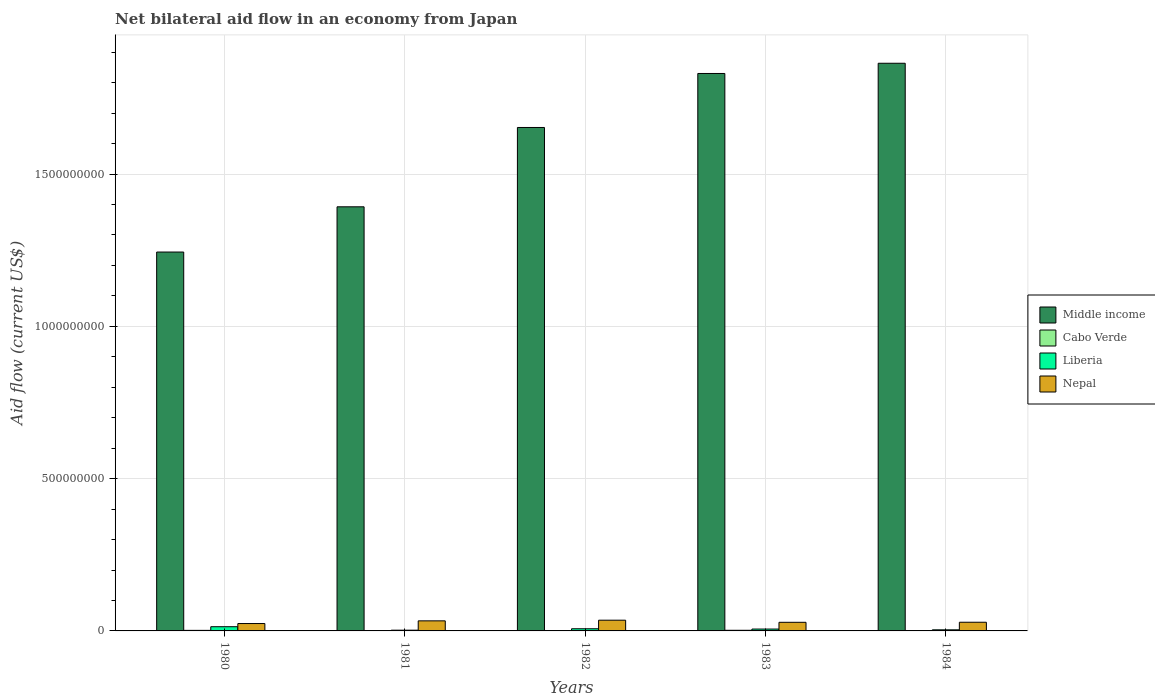How many groups of bars are there?
Give a very brief answer. 5. Are the number of bars per tick equal to the number of legend labels?
Give a very brief answer. Yes. How many bars are there on the 1st tick from the left?
Keep it short and to the point. 4. How many bars are there on the 1st tick from the right?
Provide a succinct answer. 4. In how many cases, is the number of bars for a given year not equal to the number of legend labels?
Your answer should be compact. 0. What is the net bilateral aid flow in Cabo Verde in 1984?
Provide a succinct answer. 1.02e+06. Across all years, what is the maximum net bilateral aid flow in Middle income?
Provide a succinct answer. 1.86e+09. Across all years, what is the minimum net bilateral aid flow in Middle income?
Offer a terse response. 1.24e+09. What is the total net bilateral aid flow in Middle income in the graph?
Provide a succinct answer. 7.98e+09. What is the difference between the net bilateral aid flow in Middle income in 1980 and that in 1982?
Provide a succinct answer. -4.09e+08. What is the difference between the net bilateral aid flow in Middle income in 1982 and the net bilateral aid flow in Liberia in 1980?
Make the answer very short. 1.64e+09. What is the average net bilateral aid flow in Nepal per year?
Your response must be concise. 2.99e+07. In the year 1982, what is the difference between the net bilateral aid flow in Middle income and net bilateral aid flow in Cabo Verde?
Make the answer very short. 1.65e+09. What is the ratio of the net bilateral aid flow in Middle income in 1982 to that in 1983?
Your response must be concise. 0.9. What is the difference between the highest and the lowest net bilateral aid flow in Cabo Verde?
Make the answer very short. 1.08e+06. Is the sum of the net bilateral aid flow in Liberia in 1981 and 1984 greater than the maximum net bilateral aid flow in Cabo Verde across all years?
Offer a very short reply. Yes. Is it the case that in every year, the sum of the net bilateral aid flow in Cabo Verde and net bilateral aid flow in Middle income is greater than the sum of net bilateral aid flow in Liberia and net bilateral aid flow in Nepal?
Make the answer very short. Yes. What does the 4th bar from the left in 1981 represents?
Offer a terse response. Nepal. What does the 1st bar from the right in 1980 represents?
Provide a short and direct response. Nepal. Is it the case that in every year, the sum of the net bilateral aid flow in Nepal and net bilateral aid flow in Liberia is greater than the net bilateral aid flow in Middle income?
Keep it short and to the point. No. How many bars are there?
Your answer should be compact. 20. How many years are there in the graph?
Your response must be concise. 5. What is the difference between two consecutive major ticks on the Y-axis?
Give a very brief answer. 5.00e+08. Are the values on the major ticks of Y-axis written in scientific E-notation?
Provide a succinct answer. No. How many legend labels are there?
Offer a very short reply. 4. What is the title of the graph?
Give a very brief answer. Net bilateral aid flow in an economy from Japan. What is the label or title of the Y-axis?
Make the answer very short. Aid flow (current US$). What is the Aid flow (current US$) of Middle income in 1980?
Your answer should be very brief. 1.24e+09. What is the Aid flow (current US$) in Cabo Verde in 1980?
Offer a terse response. 1.82e+06. What is the Aid flow (current US$) in Liberia in 1980?
Offer a very short reply. 1.38e+07. What is the Aid flow (current US$) of Nepal in 1980?
Your answer should be compact. 2.43e+07. What is the Aid flow (current US$) of Middle income in 1981?
Your answer should be very brief. 1.39e+09. What is the Aid flow (current US$) in Cabo Verde in 1981?
Provide a succinct answer. 1.07e+06. What is the Aid flow (current US$) in Liberia in 1981?
Your answer should be very brief. 2.46e+06. What is the Aid flow (current US$) of Nepal in 1981?
Keep it short and to the point. 3.31e+07. What is the Aid flow (current US$) of Middle income in 1982?
Provide a short and direct response. 1.65e+09. What is the Aid flow (current US$) in Cabo Verde in 1982?
Provide a succinct answer. 1.25e+06. What is the Aid flow (current US$) of Liberia in 1982?
Your answer should be compact. 7.10e+06. What is the Aid flow (current US$) in Nepal in 1982?
Your answer should be compact. 3.52e+07. What is the Aid flow (current US$) of Middle income in 1983?
Keep it short and to the point. 1.83e+09. What is the Aid flow (current US$) of Cabo Verde in 1983?
Keep it short and to the point. 2.10e+06. What is the Aid flow (current US$) of Liberia in 1983?
Keep it short and to the point. 6.13e+06. What is the Aid flow (current US$) of Nepal in 1983?
Your answer should be compact. 2.83e+07. What is the Aid flow (current US$) in Middle income in 1984?
Provide a short and direct response. 1.86e+09. What is the Aid flow (current US$) of Cabo Verde in 1984?
Give a very brief answer. 1.02e+06. What is the Aid flow (current US$) of Liberia in 1984?
Ensure brevity in your answer.  3.63e+06. What is the Aid flow (current US$) of Nepal in 1984?
Your response must be concise. 2.85e+07. Across all years, what is the maximum Aid flow (current US$) in Middle income?
Offer a terse response. 1.86e+09. Across all years, what is the maximum Aid flow (current US$) of Cabo Verde?
Offer a terse response. 2.10e+06. Across all years, what is the maximum Aid flow (current US$) of Liberia?
Your response must be concise. 1.38e+07. Across all years, what is the maximum Aid flow (current US$) of Nepal?
Provide a succinct answer. 3.52e+07. Across all years, what is the minimum Aid flow (current US$) in Middle income?
Offer a very short reply. 1.24e+09. Across all years, what is the minimum Aid flow (current US$) in Cabo Verde?
Make the answer very short. 1.02e+06. Across all years, what is the minimum Aid flow (current US$) of Liberia?
Offer a terse response. 2.46e+06. Across all years, what is the minimum Aid flow (current US$) of Nepal?
Provide a succinct answer. 2.43e+07. What is the total Aid flow (current US$) in Middle income in the graph?
Give a very brief answer. 7.98e+09. What is the total Aid flow (current US$) of Cabo Verde in the graph?
Provide a succinct answer. 7.26e+06. What is the total Aid flow (current US$) in Liberia in the graph?
Offer a very short reply. 3.32e+07. What is the total Aid flow (current US$) in Nepal in the graph?
Give a very brief answer. 1.49e+08. What is the difference between the Aid flow (current US$) in Middle income in 1980 and that in 1981?
Ensure brevity in your answer.  -1.49e+08. What is the difference between the Aid flow (current US$) of Cabo Verde in 1980 and that in 1981?
Your answer should be very brief. 7.50e+05. What is the difference between the Aid flow (current US$) of Liberia in 1980 and that in 1981?
Make the answer very short. 1.14e+07. What is the difference between the Aid flow (current US$) of Nepal in 1980 and that in 1981?
Your answer should be compact. -8.81e+06. What is the difference between the Aid flow (current US$) of Middle income in 1980 and that in 1982?
Offer a very short reply. -4.09e+08. What is the difference between the Aid flow (current US$) in Cabo Verde in 1980 and that in 1982?
Give a very brief answer. 5.70e+05. What is the difference between the Aid flow (current US$) in Liberia in 1980 and that in 1982?
Your answer should be very brief. 6.75e+06. What is the difference between the Aid flow (current US$) of Nepal in 1980 and that in 1982?
Provide a succinct answer. -1.10e+07. What is the difference between the Aid flow (current US$) of Middle income in 1980 and that in 1983?
Provide a short and direct response. -5.86e+08. What is the difference between the Aid flow (current US$) in Cabo Verde in 1980 and that in 1983?
Your answer should be compact. -2.80e+05. What is the difference between the Aid flow (current US$) of Liberia in 1980 and that in 1983?
Your answer should be compact. 7.72e+06. What is the difference between the Aid flow (current US$) in Nepal in 1980 and that in 1983?
Your answer should be compact. -4.05e+06. What is the difference between the Aid flow (current US$) in Middle income in 1980 and that in 1984?
Provide a short and direct response. -6.20e+08. What is the difference between the Aid flow (current US$) in Cabo Verde in 1980 and that in 1984?
Offer a terse response. 8.00e+05. What is the difference between the Aid flow (current US$) of Liberia in 1980 and that in 1984?
Your answer should be compact. 1.02e+07. What is the difference between the Aid flow (current US$) of Nepal in 1980 and that in 1984?
Keep it short and to the point. -4.26e+06. What is the difference between the Aid flow (current US$) in Middle income in 1981 and that in 1982?
Keep it short and to the point. -2.60e+08. What is the difference between the Aid flow (current US$) in Cabo Verde in 1981 and that in 1982?
Your answer should be very brief. -1.80e+05. What is the difference between the Aid flow (current US$) of Liberia in 1981 and that in 1982?
Provide a succinct answer. -4.64e+06. What is the difference between the Aid flow (current US$) in Nepal in 1981 and that in 1982?
Offer a very short reply. -2.15e+06. What is the difference between the Aid flow (current US$) in Middle income in 1981 and that in 1983?
Your answer should be compact. -4.38e+08. What is the difference between the Aid flow (current US$) of Cabo Verde in 1981 and that in 1983?
Offer a terse response. -1.03e+06. What is the difference between the Aid flow (current US$) of Liberia in 1981 and that in 1983?
Keep it short and to the point. -3.67e+06. What is the difference between the Aid flow (current US$) of Nepal in 1981 and that in 1983?
Your response must be concise. 4.76e+06. What is the difference between the Aid flow (current US$) in Middle income in 1981 and that in 1984?
Your answer should be very brief. -4.71e+08. What is the difference between the Aid flow (current US$) of Cabo Verde in 1981 and that in 1984?
Your answer should be very brief. 5.00e+04. What is the difference between the Aid flow (current US$) of Liberia in 1981 and that in 1984?
Your answer should be compact. -1.17e+06. What is the difference between the Aid flow (current US$) of Nepal in 1981 and that in 1984?
Your answer should be compact. 4.55e+06. What is the difference between the Aid flow (current US$) in Middle income in 1982 and that in 1983?
Offer a very short reply. -1.77e+08. What is the difference between the Aid flow (current US$) of Cabo Verde in 1982 and that in 1983?
Your answer should be compact. -8.50e+05. What is the difference between the Aid flow (current US$) of Liberia in 1982 and that in 1983?
Offer a terse response. 9.70e+05. What is the difference between the Aid flow (current US$) in Nepal in 1982 and that in 1983?
Your answer should be compact. 6.91e+06. What is the difference between the Aid flow (current US$) of Middle income in 1982 and that in 1984?
Provide a short and direct response. -2.11e+08. What is the difference between the Aid flow (current US$) in Liberia in 1982 and that in 1984?
Keep it short and to the point. 3.47e+06. What is the difference between the Aid flow (current US$) in Nepal in 1982 and that in 1984?
Your answer should be compact. 6.70e+06. What is the difference between the Aid flow (current US$) in Middle income in 1983 and that in 1984?
Make the answer very short. -3.35e+07. What is the difference between the Aid flow (current US$) in Cabo Verde in 1983 and that in 1984?
Your answer should be compact. 1.08e+06. What is the difference between the Aid flow (current US$) of Liberia in 1983 and that in 1984?
Your response must be concise. 2.50e+06. What is the difference between the Aid flow (current US$) in Middle income in 1980 and the Aid flow (current US$) in Cabo Verde in 1981?
Keep it short and to the point. 1.24e+09. What is the difference between the Aid flow (current US$) in Middle income in 1980 and the Aid flow (current US$) in Liberia in 1981?
Give a very brief answer. 1.24e+09. What is the difference between the Aid flow (current US$) in Middle income in 1980 and the Aid flow (current US$) in Nepal in 1981?
Make the answer very short. 1.21e+09. What is the difference between the Aid flow (current US$) in Cabo Verde in 1980 and the Aid flow (current US$) in Liberia in 1981?
Offer a terse response. -6.40e+05. What is the difference between the Aid flow (current US$) of Cabo Verde in 1980 and the Aid flow (current US$) of Nepal in 1981?
Offer a very short reply. -3.12e+07. What is the difference between the Aid flow (current US$) of Liberia in 1980 and the Aid flow (current US$) of Nepal in 1981?
Provide a short and direct response. -1.92e+07. What is the difference between the Aid flow (current US$) in Middle income in 1980 and the Aid flow (current US$) in Cabo Verde in 1982?
Provide a short and direct response. 1.24e+09. What is the difference between the Aid flow (current US$) of Middle income in 1980 and the Aid flow (current US$) of Liberia in 1982?
Provide a short and direct response. 1.24e+09. What is the difference between the Aid flow (current US$) in Middle income in 1980 and the Aid flow (current US$) in Nepal in 1982?
Your answer should be compact. 1.21e+09. What is the difference between the Aid flow (current US$) of Cabo Verde in 1980 and the Aid flow (current US$) of Liberia in 1982?
Offer a very short reply. -5.28e+06. What is the difference between the Aid flow (current US$) of Cabo Verde in 1980 and the Aid flow (current US$) of Nepal in 1982?
Provide a succinct answer. -3.34e+07. What is the difference between the Aid flow (current US$) in Liberia in 1980 and the Aid flow (current US$) in Nepal in 1982?
Give a very brief answer. -2.14e+07. What is the difference between the Aid flow (current US$) in Middle income in 1980 and the Aid flow (current US$) in Cabo Verde in 1983?
Your answer should be compact. 1.24e+09. What is the difference between the Aid flow (current US$) of Middle income in 1980 and the Aid flow (current US$) of Liberia in 1983?
Ensure brevity in your answer.  1.24e+09. What is the difference between the Aid flow (current US$) of Middle income in 1980 and the Aid flow (current US$) of Nepal in 1983?
Your answer should be compact. 1.22e+09. What is the difference between the Aid flow (current US$) in Cabo Verde in 1980 and the Aid flow (current US$) in Liberia in 1983?
Your answer should be very brief. -4.31e+06. What is the difference between the Aid flow (current US$) of Cabo Verde in 1980 and the Aid flow (current US$) of Nepal in 1983?
Make the answer very short. -2.65e+07. What is the difference between the Aid flow (current US$) of Liberia in 1980 and the Aid flow (current US$) of Nepal in 1983?
Keep it short and to the point. -1.45e+07. What is the difference between the Aid flow (current US$) in Middle income in 1980 and the Aid flow (current US$) in Cabo Verde in 1984?
Keep it short and to the point. 1.24e+09. What is the difference between the Aid flow (current US$) of Middle income in 1980 and the Aid flow (current US$) of Liberia in 1984?
Keep it short and to the point. 1.24e+09. What is the difference between the Aid flow (current US$) of Middle income in 1980 and the Aid flow (current US$) of Nepal in 1984?
Give a very brief answer. 1.22e+09. What is the difference between the Aid flow (current US$) in Cabo Verde in 1980 and the Aid flow (current US$) in Liberia in 1984?
Your response must be concise. -1.81e+06. What is the difference between the Aid flow (current US$) of Cabo Verde in 1980 and the Aid flow (current US$) of Nepal in 1984?
Your answer should be compact. -2.67e+07. What is the difference between the Aid flow (current US$) in Liberia in 1980 and the Aid flow (current US$) in Nepal in 1984?
Offer a very short reply. -1.47e+07. What is the difference between the Aid flow (current US$) in Middle income in 1981 and the Aid flow (current US$) in Cabo Verde in 1982?
Provide a short and direct response. 1.39e+09. What is the difference between the Aid flow (current US$) in Middle income in 1981 and the Aid flow (current US$) in Liberia in 1982?
Your answer should be compact. 1.39e+09. What is the difference between the Aid flow (current US$) of Middle income in 1981 and the Aid flow (current US$) of Nepal in 1982?
Your response must be concise. 1.36e+09. What is the difference between the Aid flow (current US$) of Cabo Verde in 1981 and the Aid flow (current US$) of Liberia in 1982?
Offer a terse response. -6.03e+06. What is the difference between the Aid flow (current US$) in Cabo Verde in 1981 and the Aid flow (current US$) in Nepal in 1982?
Offer a very short reply. -3.42e+07. What is the difference between the Aid flow (current US$) of Liberia in 1981 and the Aid flow (current US$) of Nepal in 1982?
Ensure brevity in your answer.  -3.28e+07. What is the difference between the Aid flow (current US$) in Middle income in 1981 and the Aid flow (current US$) in Cabo Verde in 1983?
Give a very brief answer. 1.39e+09. What is the difference between the Aid flow (current US$) in Middle income in 1981 and the Aid flow (current US$) in Liberia in 1983?
Offer a very short reply. 1.39e+09. What is the difference between the Aid flow (current US$) in Middle income in 1981 and the Aid flow (current US$) in Nepal in 1983?
Give a very brief answer. 1.36e+09. What is the difference between the Aid flow (current US$) of Cabo Verde in 1981 and the Aid flow (current US$) of Liberia in 1983?
Offer a very short reply. -5.06e+06. What is the difference between the Aid flow (current US$) of Cabo Verde in 1981 and the Aid flow (current US$) of Nepal in 1983?
Give a very brief answer. -2.72e+07. What is the difference between the Aid flow (current US$) in Liberia in 1981 and the Aid flow (current US$) in Nepal in 1983?
Provide a short and direct response. -2.58e+07. What is the difference between the Aid flow (current US$) in Middle income in 1981 and the Aid flow (current US$) in Cabo Verde in 1984?
Offer a very short reply. 1.39e+09. What is the difference between the Aid flow (current US$) in Middle income in 1981 and the Aid flow (current US$) in Liberia in 1984?
Offer a terse response. 1.39e+09. What is the difference between the Aid flow (current US$) in Middle income in 1981 and the Aid flow (current US$) in Nepal in 1984?
Provide a succinct answer. 1.36e+09. What is the difference between the Aid flow (current US$) of Cabo Verde in 1981 and the Aid flow (current US$) of Liberia in 1984?
Provide a short and direct response. -2.56e+06. What is the difference between the Aid flow (current US$) in Cabo Verde in 1981 and the Aid flow (current US$) in Nepal in 1984?
Your answer should be compact. -2.74e+07. What is the difference between the Aid flow (current US$) in Liberia in 1981 and the Aid flow (current US$) in Nepal in 1984?
Make the answer very short. -2.61e+07. What is the difference between the Aid flow (current US$) of Middle income in 1982 and the Aid flow (current US$) of Cabo Verde in 1983?
Provide a short and direct response. 1.65e+09. What is the difference between the Aid flow (current US$) of Middle income in 1982 and the Aid flow (current US$) of Liberia in 1983?
Offer a terse response. 1.65e+09. What is the difference between the Aid flow (current US$) of Middle income in 1982 and the Aid flow (current US$) of Nepal in 1983?
Make the answer very short. 1.62e+09. What is the difference between the Aid flow (current US$) of Cabo Verde in 1982 and the Aid flow (current US$) of Liberia in 1983?
Ensure brevity in your answer.  -4.88e+06. What is the difference between the Aid flow (current US$) of Cabo Verde in 1982 and the Aid flow (current US$) of Nepal in 1983?
Make the answer very short. -2.71e+07. What is the difference between the Aid flow (current US$) of Liberia in 1982 and the Aid flow (current US$) of Nepal in 1983?
Your answer should be very brief. -2.12e+07. What is the difference between the Aid flow (current US$) in Middle income in 1982 and the Aid flow (current US$) in Cabo Verde in 1984?
Provide a short and direct response. 1.65e+09. What is the difference between the Aid flow (current US$) of Middle income in 1982 and the Aid flow (current US$) of Liberia in 1984?
Your response must be concise. 1.65e+09. What is the difference between the Aid flow (current US$) in Middle income in 1982 and the Aid flow (current US$) in Nepal in 1984?
Make the answer very short. 1.62e+09. What is the difference between the Aid flow (current US$) in Cabo Verde in 1982 and the Aid flow (current US$) in Liberia in 1984?
Keep it short and to the point. -2.38e+06. What is the difference between the Aid flow (current US$) of Cabo Verde in 1982 and the Aid flow (current US$) of Nepal in 1984?
Give a very brief answer. -2.73e+07. What is the difference between the Aid flow (current US$) of Liberia in 1982 and the Aid flow (current US$) of Nepal in 1984?
Make the answer very short. -2.14e+07. What is the difference between the Aid flow (current US$) in Middle income in 1983 and the Aid flow (current US$) in Cabo Verde in 1984?
Make the answer very short. 1.83e+09. What is the difference between the Aid flow (current US$) in Middle income in 1983 and the Aid flow (current US$) in Liberia in 1984?
Ensure brevity in your answer.  1.83e+09. What is the difference between the Aid flow (current US$) in Middle income in 1983 and the Aid flow (current US$) in Nepal in 1984?
Provide a short and direct response. 1.80e+09. What is the difference between the Aid flow (current US$) in Cabo Verde in 1983 and the Aid flow (current US$) in Liberia in 1984?
Ensure brevity in your answer.  -1.53e+06. What is the difference between the Aid flow (current US$) in Cabo Verde in 1983 and the Aid flow (current US$) in Nepal in 1984?
Your answer should be very brief. -2.64e+07. What is the difference between the Aid flow (current US$) in Liberia in 1983 and the Aid flow (current US$) in Nepal in 1984?
Offer a terse response. -2.24e+07. What is the average Aid flow (current US$) of Middle income per year?
Make the answer very short. 1.60e+09. What is the average Aid flow (current US$) of Cabo Verde per year?
Make the answer very short. 1.45e+06. What is the average Aid flow (current US$) in Liberia per year?
Make the answer very short. 6.63e+06. What is the average Aid flow (current US$) of Nepal per year?
Keep it short and to the point. 2.99e+07. In the year 1980, what is the difference between the Aid flow (current US$) of Middle income and Aid flow (current US$) of Cabo Verde?
Keep it short and to the point. 1.24e+09. In the year 1980, what is the difference between the Aid flow (current US$) of Middle income and Aid flow (current US$) of Liberia?
Make the answer very short. 1.23e+09. In the year 1980, what is the difference between the Aid flow (current US$) in Middle income and Aid flow (current US$) in Nepal?
Keep it short and to the point. 1.22e+09. In the year 1980, what is the difference between the Aid flow (current US$) in Cabo Verde and Aid flow (current US$) in Liberia?
Provide a short and direct response. -1.20e+07. In the year 1980, what is the difference between the Aid flow (current US$) in Cabo Verde and Aid flow (current US$) in Nepal?
Provide a short and direct response. -2.24e+07. In the year 1980, what is the difference between the Aid flow (current US$) in Liberia and Aid flow (current US$) in Nepal?
Provide a succinct answer. -1.04e+07. In the year 1981, what is the difference between the Aid flow (current US$) of Middle income and Aid flow (current US$) of Cabo Verde?
Your response must be concise. 1.39e+09. In the year 1981, what is the difference between the Aid flow (current US$) in Middle income and Aid flow (current US$) in Liberia?
Provide a succinct answer. 1.39e+09. In the year 1981, what is the difference between the Aid flow (current US$) of Middle income and Aid flow (current US$) of Nepal?
Your answer should be compact. 1.36e+09. In the year 1981, what is the difference between the Aid flow (current US$) of Cabo Verde and Aid flow (current US$) of Liberia?
Your answer should be very brief. -1.39e+06. In the year 1981, what is the difference between the Aid flow (current US$) of Cabo Verde and Aid flow (current US$) of Nepal?
Your response must be concise. -3.20e+07. In the year 1981, what is the difference between the Aid flow (current US$) of Liberia and Aid flow (current US$) of Nepal?
Provide a short and direct response. -3.06e+07. In the year 1982, what is the difference between the Aid flow (current US$) in Middle income and Aid flow (current US$) in Cabo Verde?
Ensure brevity in your answer.  1.65e+09. In the year 1982, what is the difference between the Aid flow (current US$) of Middle income and Aid flow (current US$) of Liberia?
Provide a succinct answer. 1.65e+09. In the year 1982, what is the difference between the Aid flow (current US$) in Middle income and Aid flow (current US$) in Nepal?
Make the answer very short. 1.62e+09. In the year 1982, what is the difference between the Aid flow (current US$) in Cabo Verde and Aid flow (current US$) in Liberia?
Keep it short and to the point. -5.85e+06. In the year 1982, what is the difference between the Aid flow (current US$) of Cabo Verde and Aid flow (current US$) of Nepal?
Provide a short and direct response. -3.40e+07. In the year 1982, what is the difference between the Aid flow (current US$) in Liberia and Aid flow (current US$) in Nepal?
Offer a terse response. -2.81e+07. In the year 1983, what is the difference between the Aid flow (current US$) of Middle income and Aid flow (current US$) of Cabo Verde?
Provide a succinct answer. 1.83e+09. In the year 1983, what is the difference between the Aid flow (current US$) in Middle income and Aid flow (current US$) in Liberia?
Ensure brevity in your answer.  1.82e+09. In the year 1983, what is the difference between the Aid flow (current US$) in Middle income and Aid flow (current US$) in Nepal?
Provide a short and direct response. 1.80e+09. In the year 1983, what is the difference between the Aid flow (current US$) of Cabo Verde and Aid flow (current US$) of Liberia?
Provide a short and direct response. -4.03e+06. In the year 1983, what is the difference between the Aid flow (current US$) in Cabo Verde and Aid flow (current US$) in Nepal?
Your answer should be compact. -2.62e+07. In the year 1983, what is the difference between the Aid flow (current US$) in Liberia and Aid flow (current US$) in Nepal?
Keep it short and to the point. -2.22e+07. In the year 1984, what is the difference between the Aid flow (current US$) of Middle income and Aid flow (current US$) of Cabo Verde?
Give a very brief answer. 1.86e+09. In the year 1984, what is the difference between the Aid flow (current US$) in Middle income and Aid flow (current US$) in Liberia?
Offer a terse response. 1.86e+09. In the year 1984, what is the difference between the Aid flow (current US$) in Middle income and Aid flow (current US$) in Nepal?
Provide a short and direct response. 1.84e+09. In the year 1984, what is the difference between the Aid flow (current US$) in Cabo Verde and Aid flow (current US$) in Liberia?
Keep it short and to the point. -2.61e+06. In the year 1984, what is the difference between the Aid flow (current US$) of Cabo Verde and Aid flow (current US$) of Nepal?
Offer a terse response. -2.75e+07. In the year 1984, what is the difference between the Aid flow (current US$) of Liberia and Aid flow (current US$) of Nepal?
Offer a very short reply. -2.49e+07. What is the ratio of the Aid flow (current US$) of Middle income in 1980 to that in 1981?
Offer a terse response. 0.89. What is the ratio of the Aid flow (current US$) in Cabo Verde in 1980 to that in 1981?
Your response must be concise. 1.7. What is the ratio of the Aid flow (current US$) of Liberia in 1980 to that in 1981?
Your response must be concise. 5.63. What is the ratio of the Aid flow (current US$) of Nepal in 1980 to that in 1981?
Offer a terse response. 0.73. What is the ratio of the Aid flow (current US$) of Middle income in 1980 to that in 1982?
Make the answer very short. 0.75. What is the ratio of the Aid flow (current US$) of Cabo Verde in 1980 to that in 1982?
Your answer should be very brief. 1.46. What is the ratio of the Aid flow (current US$) in Liberia in 1980 to that in 1982?
Your response must be concise. 1.95. What is the ratio of the Aid flow (current US$) in Nepal in 1980 to that in 1982?
Your answer should be very brief. 0.69. What is the ratio of the Aid flow (current US$) of Middle income in 1980 to that in 1983?
Make the answer very short. 0.68. What is the ratio of the Aid flow (current US$) of Cabo Verde in 1980 to that in 1983?
Provide a short and direct response. 0.87. What is the ratio of the Aid flow (current US$) in Liberia in 1980 to that in 1983?
Your answer should be very brief. 2.26. What is the ratio of the Aid flow (current US$) of Nepal in 1980 to that in 1983?
Your answer should be very brief. 0.86. What is the ratio of the Aid flow (current US$) of Middle income in 1980 to that in 1984?
Your answer should be compact. 0.67. What is the ratio of the Aid flow (current US$) of Cabo Verde in 1980 to that in 1984?
Offer a terse response. 1.78. What is the ratio of the Aid flow (current US$) in Liberia in 1980 to that in 1984?
Give a very brief answer. 3.82. What is the ratio of the Aid flow (current US$) of Nepal in 1980 to that in 1984?
Provide a short and direct response. 0.85. What is the ratio of the Aid flow (current US$) in Middle income in 1981 to that in 1982?
Give a very brief answer. 0.84. What is the ratio of the Aid flow (current US$) of Cabo Verde in 1981 to that in 1982?
Provide a short and direct response. 0.86. What is the ratio of the Aid flow (current US$) of Liberia in 1981 to that in 1982?
Keep it short and to the point. 0.35. What is the ratio of the Aid flow (current US$) in Nepal in 1981 to that in 1982?
Keep it short and to the point. 0.94. What is the ratio of the Aid flow (current US$) of Middle income in 1981 to that in 1983?
Your response must be concise. 0.76. What is the ratio of the Aid flow (current US$) of Cabo Verde in 1981 to that in 1983?
Your response must be concise. 0.51. What is the ratio of the Aid flow (current US$) of Liberia in 1981 to that in 1983?
Offer a terse response. 0.4. What is the ratio of the Aid flow (current US$) in Nepal in 1981 to that in 1983?
Give a very brief answer. 1.17. What is the ratio of the Aid flow (current US$) in Middle income in 1981 to that in 1984?
Your answer should be compact. 0.75. What is the ratio of the Aid flow (current US$) in Cabo Verde in 1981 to that in 1984?
Give a very brief answer. 1.05. What is the ratio of the Aid flow (current US$) of Liberia in 1981 to that in 1984?
Your response must be concise. 0.68. What is the ratio of the Aid flow (current US$) of Nepal in 1981 to that in 1984?
Offer a very short reply. 1.16. What is the ratio of the Aid flow (current US$) in Middle income in 1982 to that in 1983?
Provide a short and direct response. 0.9. What is the ratio of the Aid flow (current US$) of Cabo Verde in 1982 to that in 1983?
Offer a very short reply. 0.6. What is the ratio of the Aid flow (current US$) in Liberia in 1982 to that in 1983?
Ensure brevity in your answer.  1.16. What is the ratio of the Aid flow (current US$) in Nepal in 1982 to that in 1983?
Provide a short and direct response. 1.24. What is the ratio of the Aid flow (current US$) of Middle income in 1982 to that in 1984?
Offer a terse response. 0.89. What is the ratio of the Aid flow (current US$) of Cabo Verde in 1982 to that in 1984?
Your response must be concise. 1.23. What is the ratio of the Aid flow (current US$) of Liberia in 1982 to that in 1984?
Provide a short and direct response. 1.96. What is the ratio of the Aid flow (current US$) in Nepal in 1982 to that in 1984?
Provide a short and direct response. 1.23. What is the ratio of the Aid flow (current US$) in Cabo Verde in 1983 to that in 1984?
Your answer should be compact. 2.06. What is the ratio of the Aid flow (current US$) in Liberia in 1983 to that in 1984?
Offer a terse response. 1.69. What is the ratio of the Aid flow (current US$) of Nepal in 1983 to that in 1984?
Ensure brevity in your answer.  0.99. What is the difference between the highest and the second highest Aid flow (current US$) of Middle income?
Ensure brevity in your answer.  3.35e+07. What is the difference between the highest and the second highest Aid flow (current US$) in Cabo Verde?
Your answer should be compact. 2.80e+05. What is the difference between the highest and the second highest Aid flow (current US$) of Liberia?
Your response must be concise. 6.75e+06. What is the difference between the highest and the second highest Aid flow (current US$) in Nepal?
Your answer should be compact. 2.15e+06. What is the difference between the highest and the lowest Aid flow (current US$) in Middle income?
Ensure brevity in your answer.  6.20e+08. What is the difference between the highest and the lowest Aid flow (current US$) in Cabo Verde?
Make the answer very short. 1.08e+06. What is the difference between the highest and the lowest Aid flow (current US$) in Liberia?
Provide a short and direct response. 1.14e+07. What is the difference between the highest and the lowest Aid flow (current US$) in Nepal?
Ensure brevity in your answer.  1.10e+07. 